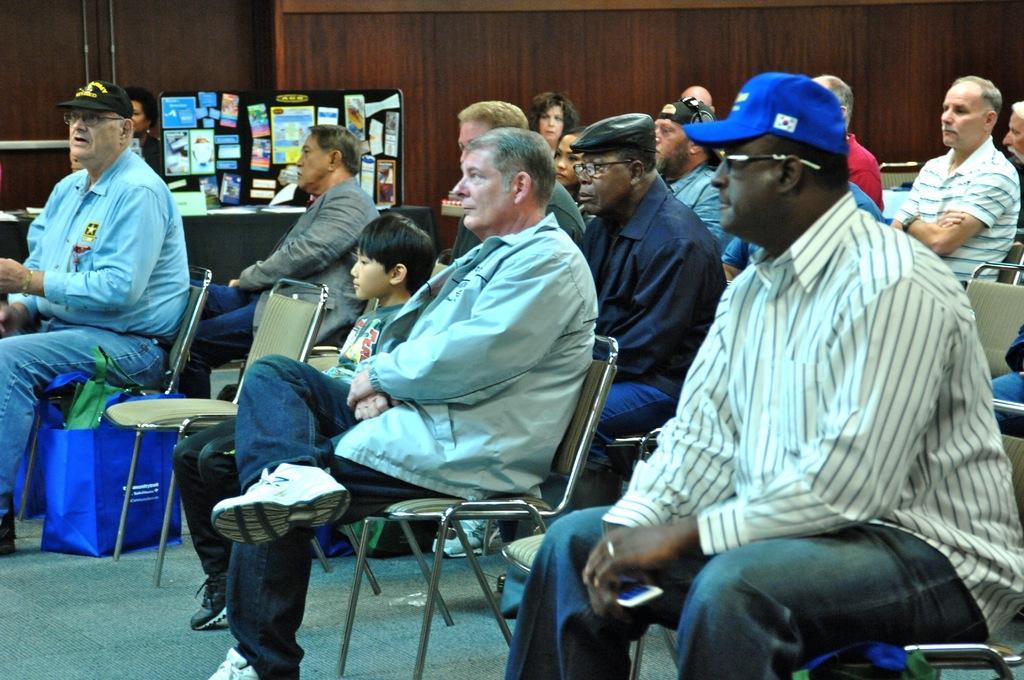Could you give a brief overview of what you see in this image? In the picture I can see people sitting on chairs among them some are wearing caps and spectacles. In the background I can see a wall empty chairs, big and some other objects. 